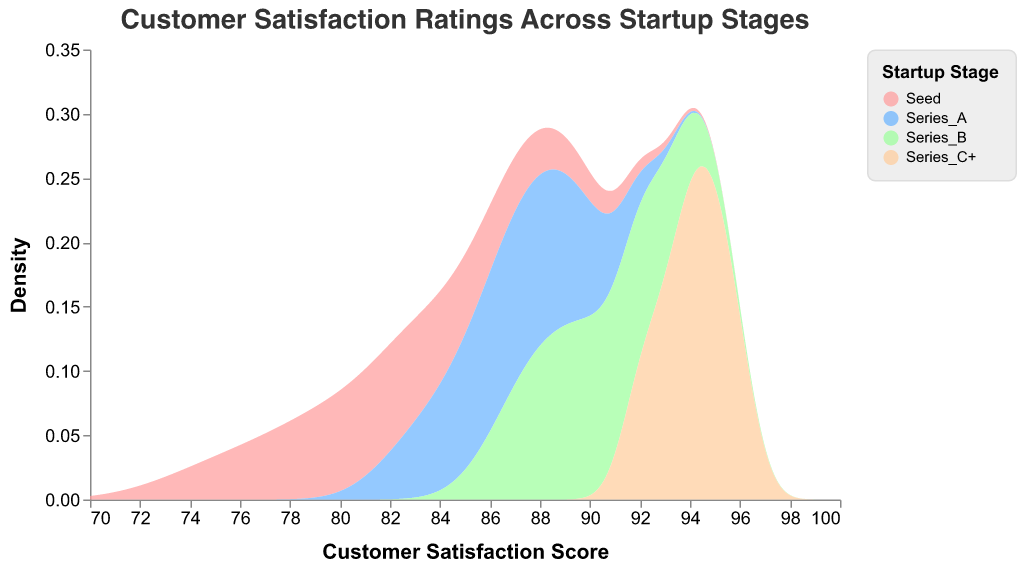What is the title of the figure? The title can be found at the top of the figure and reads "Customer Satisfaction Ratings Across Startup Stages".
Answer: Customer Satisfaction Ratings Across Startup Stages What are the axes labels in the plot? The x-axis label is "Customer Satisfaction Score," and the y-axis label is "Density." These are indicated along the respective axes.
Answer: Customer Satisfaction Score and Density Which startup stage appears to have the highest overall customer satisfaction scores? The "Series C+" stage has the highest overall customer satisfaction scores, as its density peak is located further to the right on the x-axis compared to other stages.
Answer: Series C+ In which range do the "Seed" stage satisfaction scores mainly lie? The "Seed" stage's satisfaction scores primarily lie within the range of 75 to 85, as indicated by the density peak on the x-axis.
Answer: 75 to 85 What colors represent the "Series A" and "Series B" stages? "Series A" is represented by a light blue color, and "Series B" is represented by a light green color. These can be identified by looking at the color legend in the figure.
Answer: Light blue and light green Which startup stage has the widest distribution of customer satisfaction scores? The "Seed" stage has the widest distribution, as its density plot covers the broadest range on the x-axis from approximately 75 to 89.
Answer: Seed Compare the peak density values for the "Series A" and "Series B" stages. Which one is higher? By examining the height of the peaks, "Series B" has a slightly lower density peak compared to "Series A". This can be visually assessed from the y-axis.
Answer: Series A What score appears to be the mode for "Series C+" stage? The mode, or the most frequent score, for the "Series C+" stage appears to be around 94-95, as its density peak is highest at this range on the x-axis.
Answer: 94-95 How do satisfaction ratings change as startups move from "Seed" to "Series C+" stages? As startups progress from "Seed" to "Series C+" stages, the customer satisfaction ratings generally increase. This is evidenced by the density plots shifting rightward on the x-axis.
Answer: They increase Which stage has the closest customer satisfaction score distribution to "Series B"? The "Series A" stage has a customer satisfaction score distribution closest to "Series B", as both their density plots overlap significantly and peak around the same values on the x-axis.
Answer: Series A 